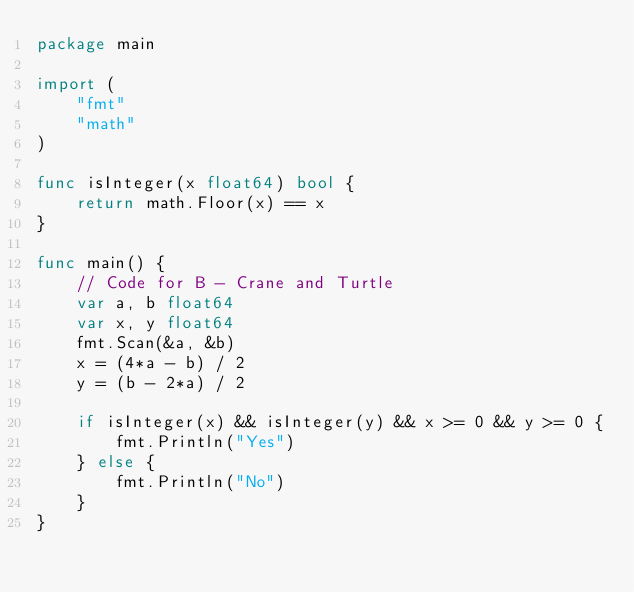Convert code to text. <code><loc_0><loc_0><loc_500><loc_500><_Go_>package main

import (
	"fmt"
	"math"
)

func isInteger(x float64) bool {
	return math.Floor(x) == x
}

func main() {
	// Code for B - Crane and Turtle
	var a, b float64
	var x, y float64
	fmt.Scan(&a, &b)
	x = (4*a - b) / 2
	y = (b - 2*a) / 2

	if isInteger(x) && isInteger(y) && x >= 0 && y >= 0 {
		fmt.Println("Yes")
	} else {
		fmt.Println("No")
	}
}
</code> 